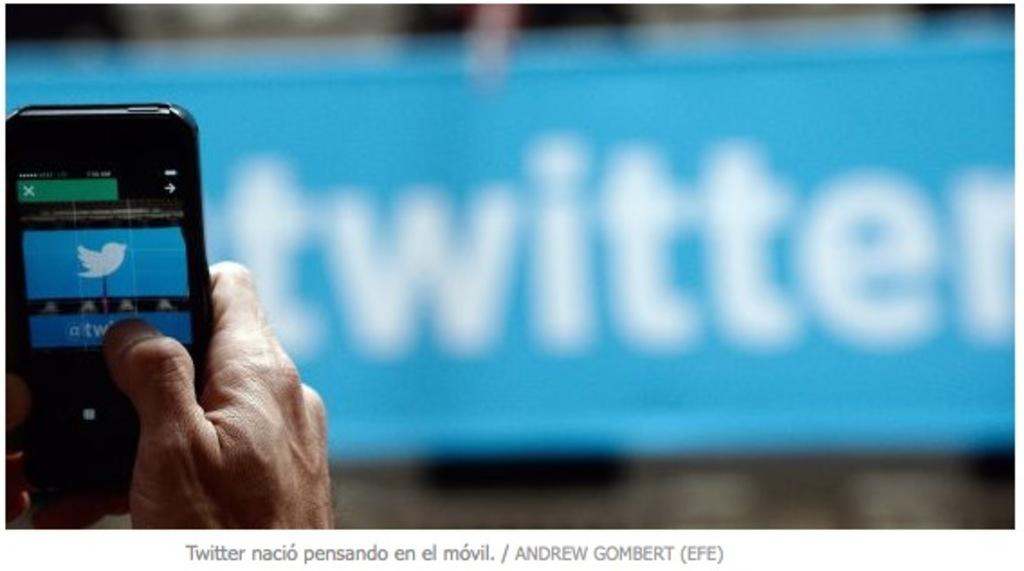<image>
Present a compact description of the photo's key features. Man taking a picture with cell phone of a twitter banner. 